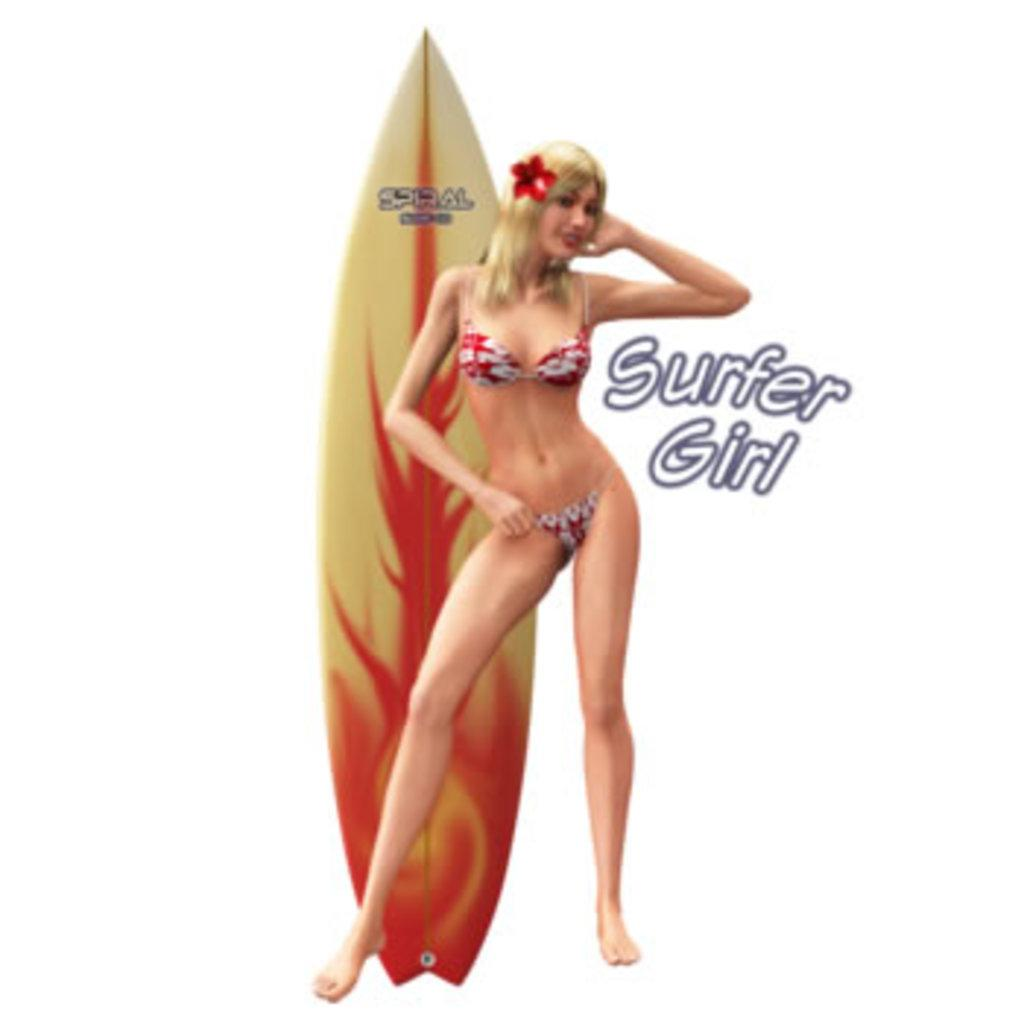What is the woman in the image doing? The woman is standing in the image. What can be seen in the woman's hair? The woman has a flower in her hair. What object is visible behind the woman? There is a surfboard behind the woman. What is written on the surfboard? There is text on the surfboard. Can you describe any other text present in the image? Yes, there is text present in the image. How much money does the woman have in her possession in the image? There is no indication of money or wealth in the image, so it cannot be determined. Are there any dinosaurs visible in the image? No, there are no dinosaurs present in the image. 